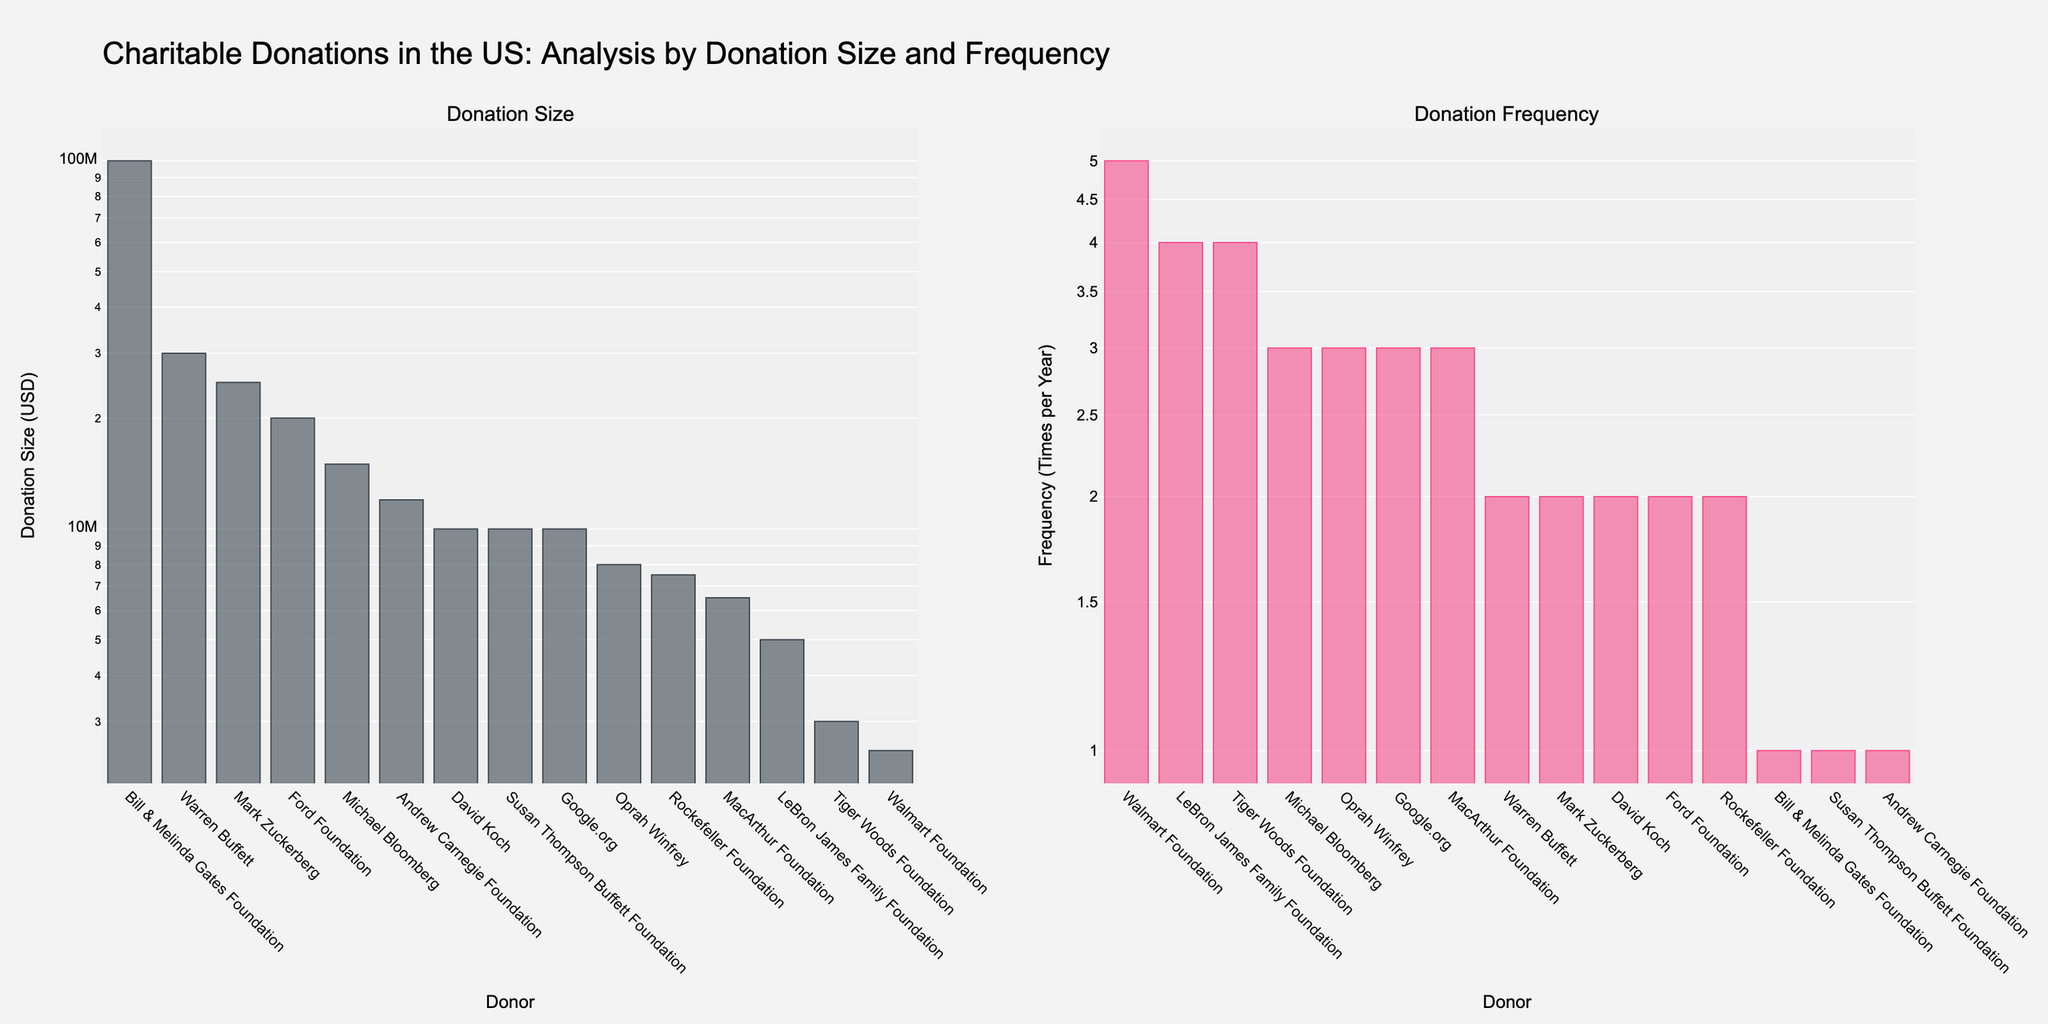what are the titles of the subplots? The subplot titles can be found above each subplot as "Donation Size" for the first subplot and "Donation Frequency" for the second subplot.
Answer: Donation Size, Donation Frequency How many donors are listed in the second subplot? Count the number of bars (data points) in the second subplot. Each bar represents one donor.
Answer: 15 Which donor has the highest donation frequency? In the "Donation Frequency" subplot, identify the bar with the highest value. The label of this bar represents the donor with the highest donation frequency.
Answer: Walmart Foundation What is the donation size of the smallest donor? In the "Donation Size" subplot, identify the bar with the smallest value. The y-axis value of this bar indicates the smallest donation size.
Answer: 2,500,000 USD Compare the donation frequency of the Rockefeller Foundation and the Susan Thompson Buffett Foundation. Locate the bars for the Rockefeller Foundation and the Susan Thompson Buffett Foundation in the "Donation Frequency" subplot and compare their heights (y-axis values).
Answer: Rockefeller Foundation: 2, Susan Thompson Buffett Foundation: 1 What is the most frequent donation amount among the donors listed? Observe the "Donation Size" subplot and identify the donation size that appears most frequently by looking for repeated y-axis values.
Answer: 10,000,000 USD Which organization has given the largest single donation? In the "Donation Size" subplot, identify the bar with the highest value. The label of this bar indicates the organization with the largest single donation.
Answer: Bill & Melinda Gates Foundation How do the donation sizes of the Ford Foundation and the Andrew Carnegie Foundation compare? Locate the bars for the Ford Foundation and the Andrew Carnegie Foundation in the "Donation Size" subplot and compare their heights (y-axis values).
Answer: Ford Foundation: 20,000,000 USD, Andrew Carnegie Foundation: 12,000,000 USD Which donor has made donations 5 times per year? In the "Donation Frequency" subplot, identify the bar with a height representing a frequency of 5 times per year. The label of this bar represents the donor making these donations.
Answer: Walmart Foundation 